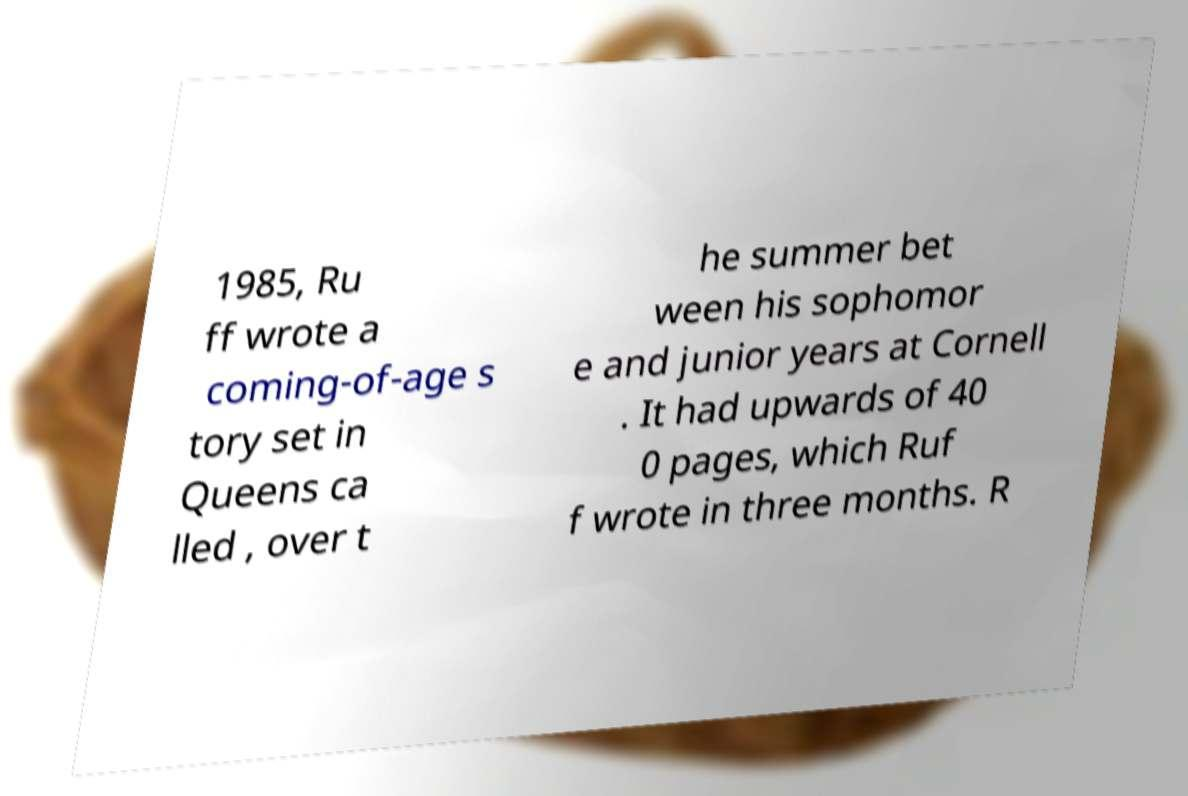Could you assist in decoding the text presented in this image and type it out clearly? 1985, Ru ff wrote a coming-of-age s tory set in Queens ca lled , over t he summer bet ween his sophomor e and junior years at Cornell . It had upwards of 40 0 pages, which Ruf f wrote in three months. R 